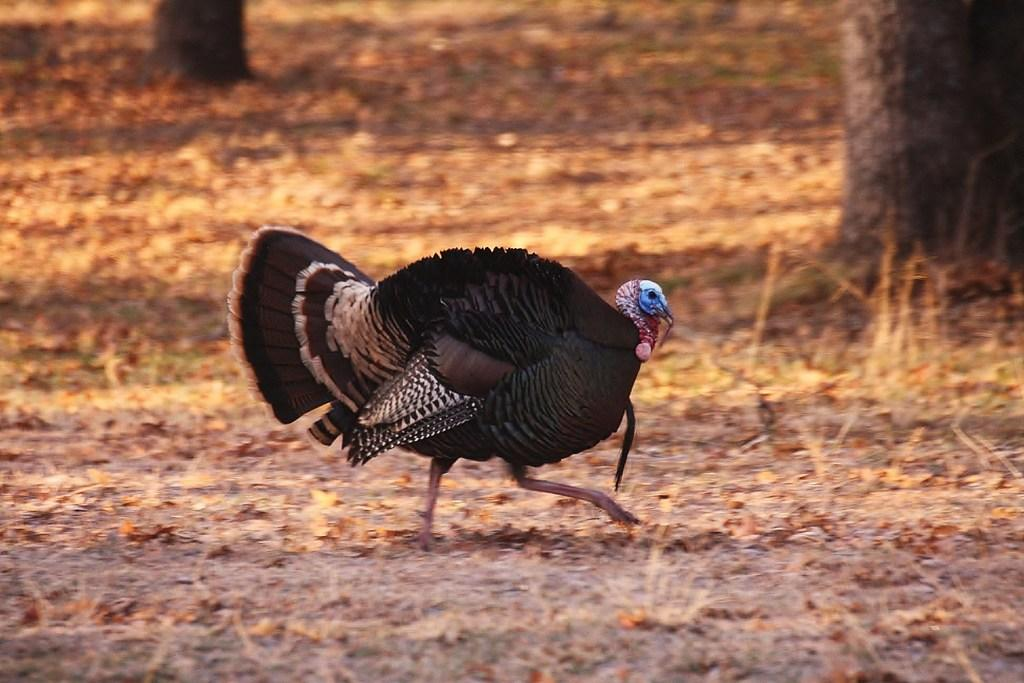What type of bird can be seen in the image? There is a wild turkey bird in the image. What is the bird doing in the image? The bird is walking on the ground. What type of vegetation is visible in the background of the image? There is grass and leaves visible in the background of the image. Where is the shelf located in the image? There is no shelf present in the image. What type of game is being played by the bird in the image? There is no game being played by the bird in the image; it is simply walking on the ground. 